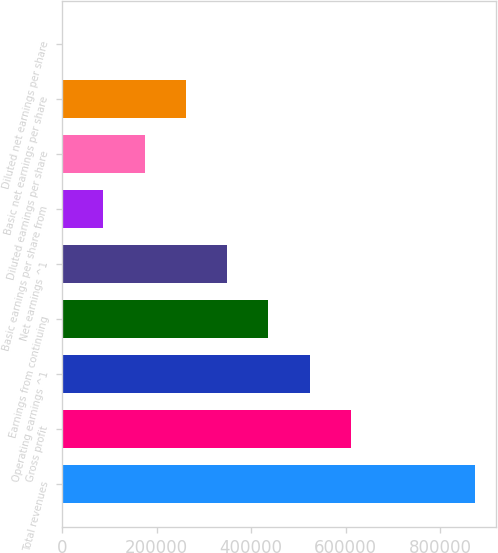<chart> <loc_0><loc_0><loc_500><loc_500><bar_chart><fcel>Total revenues<fcel>Gross profit<fcel>Operating earnings ^1<fcel>Earnings from continuing<fcel>Net earnings ^1<fcel>Basic earnings per share from<fcel>Diluted earnings per share<fcel>Basic net earnings per share<fcel>Diluted net earnings per share<nl><fcel>873579<fcel>611505<fcel>524148<fcel>436790<fcel>349432<fcel>87358.4<fcel>174716<fcel>262074<fcel>0.5<nl></chart> 